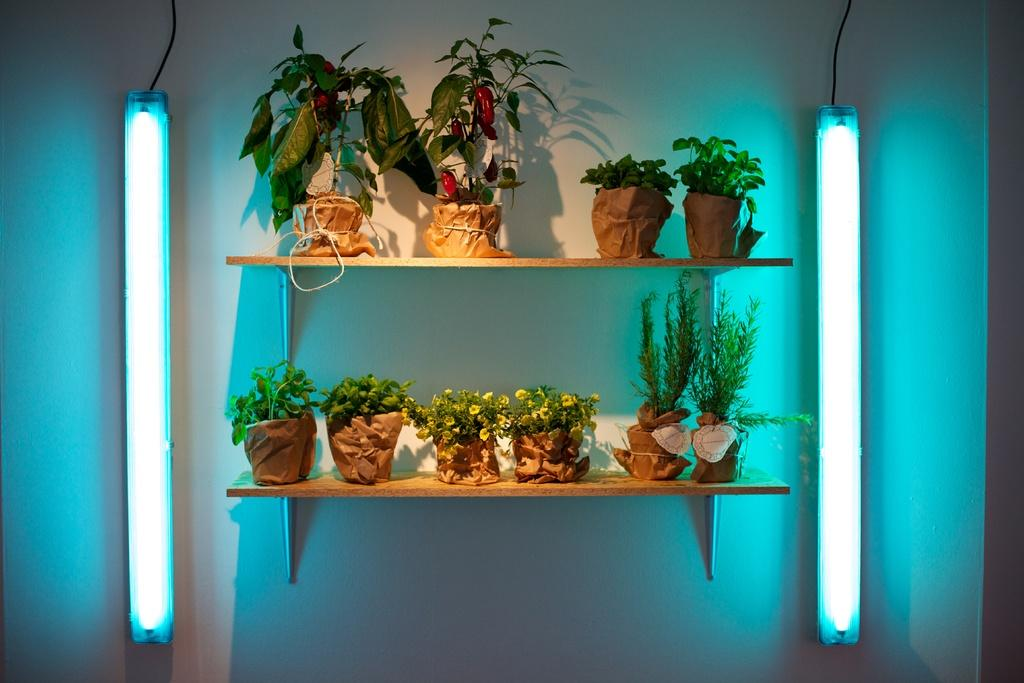What objects are present in the image that hold plants? There are flower pots in the image. How are the flower pots arranged in the image? The flower pots are arranged on shelves. What type of lighting is present in the image? There are lights at the left and right side of the image. Where are the lights attached in the image? The lights are attached to the wall. What type of rod is being used by the parent in the image? There is no rod or parent present in the image. 